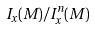Convert formula to latex. <formula><loc_0><loc_0><loc_500><loc_500>I _ { x } ( M ) / I _ { x } ^ { n } ( M )</formula> 